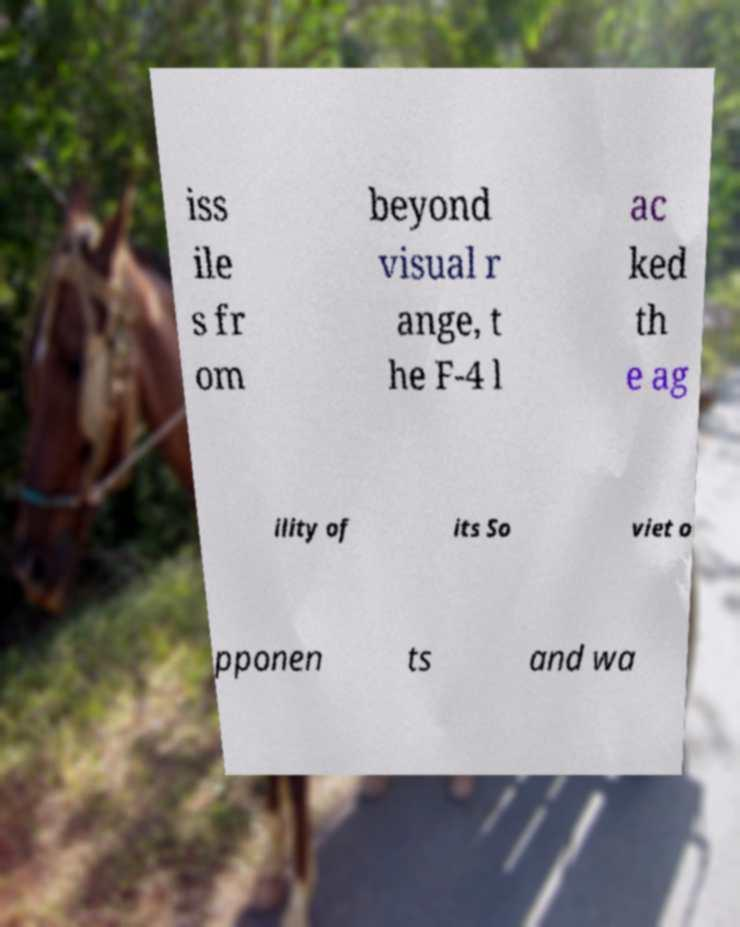For documentation purposes, I need the text within this image transcribed. Could you provide that? iss ile s fr om beyond visual r ange, t he F-4 l ac ked th e ag ility of its So viet o pponen ts and wa 